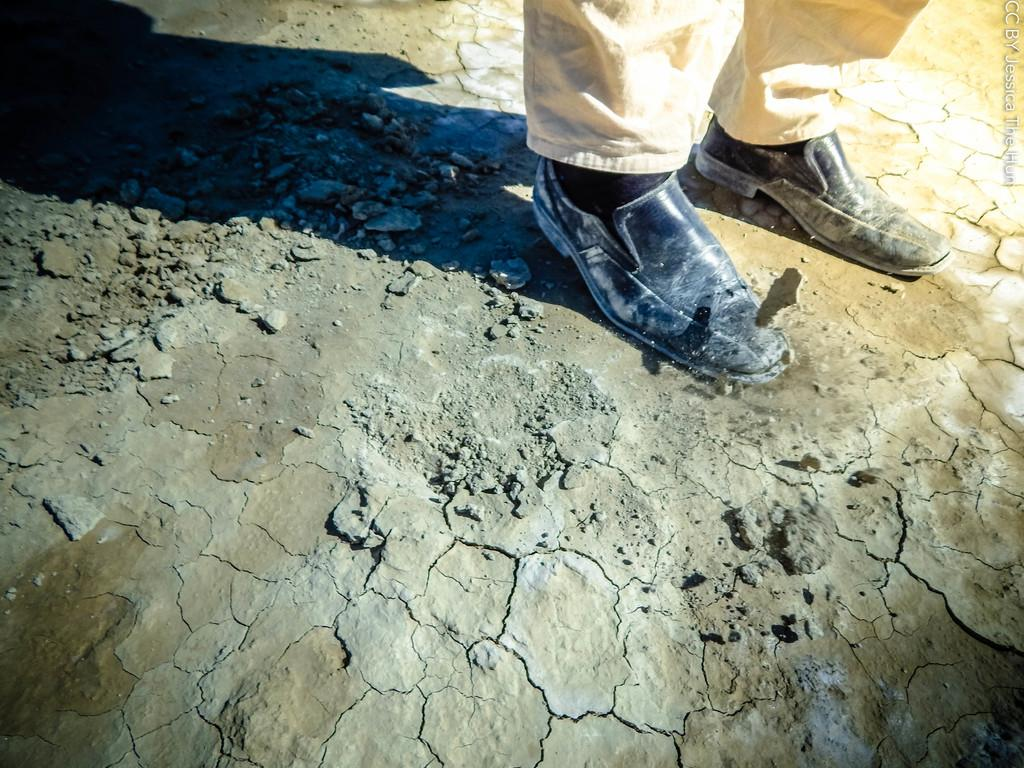What is the main subject of the image? There is a person standing in the image. What color are the person's pants? The person is wearing cream-colored pants. What type of footwear is the person wearing? The person is wearing black shoes. How would you describe the floor in the image? The floor has gray and brown colors. What type of flag is being waved by the person in the image? A: There is no flag present in the image, and the person is not waving anything. What is the person using to hold the tin in the image? There is no tin present in the image. 